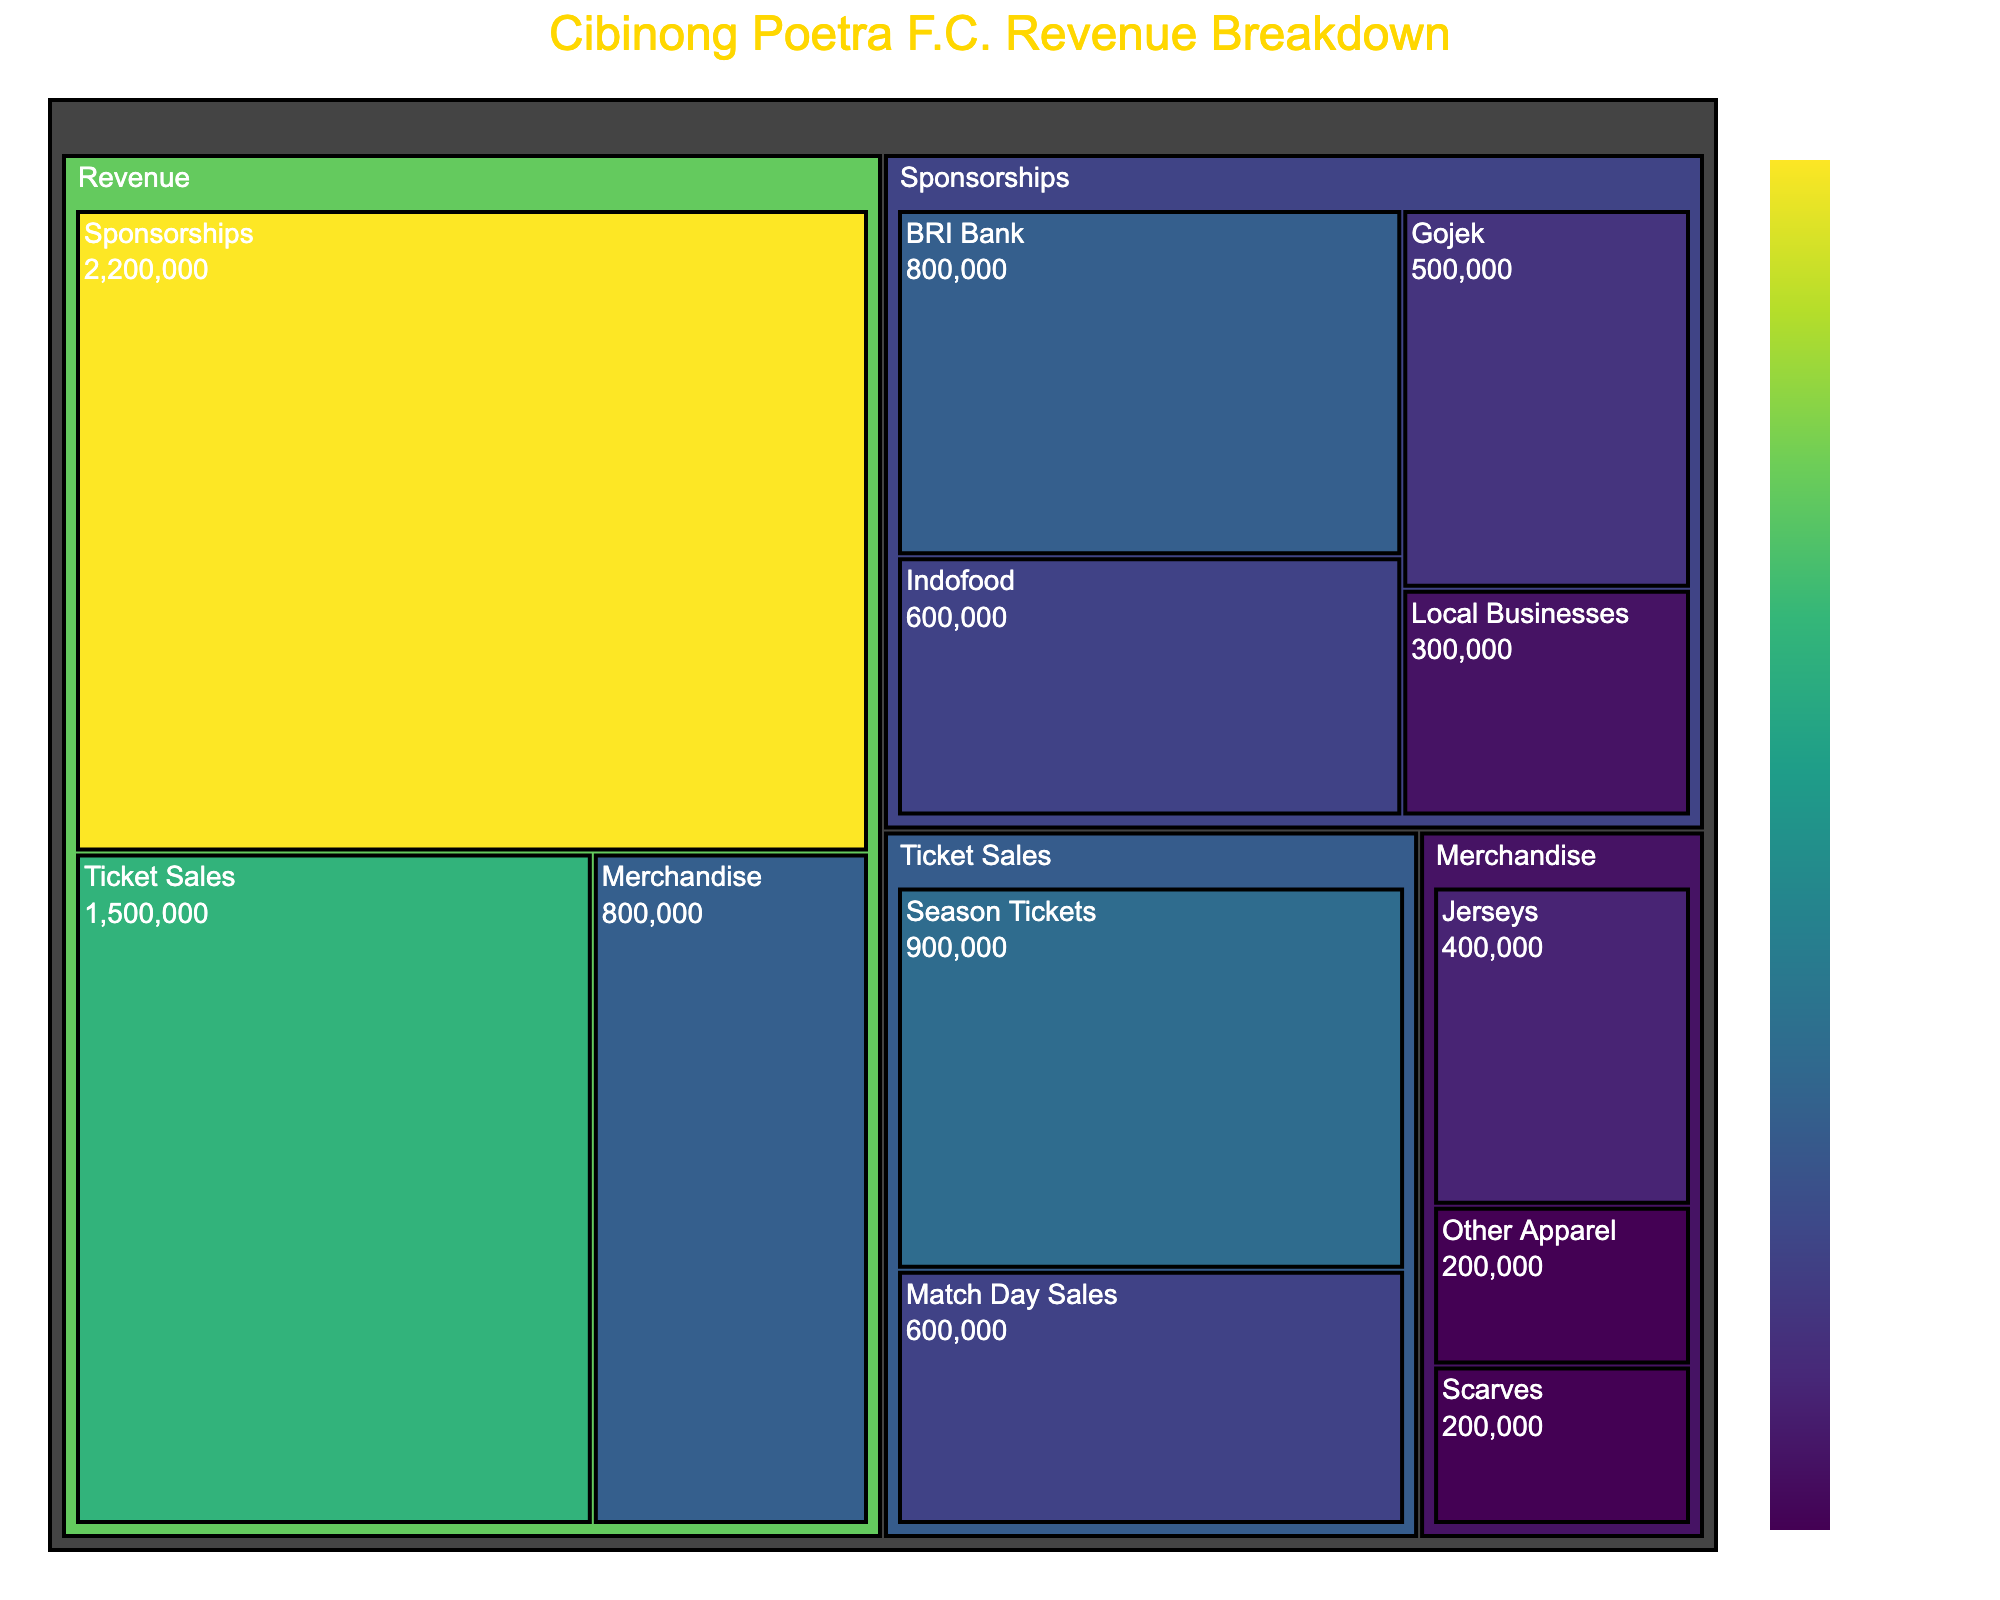What is the title of the figure? The title is usually located at the top center of the figure and specifies what the visualization represents. In this case, it is "Cibinong Poetra F.C. Revenue Breakdown".
Answer: Cibinong Poetra F.C. Revenue Breakdown Which category contributes the most to the revenue? By looking at the largest area within the treemap, one can identify the category that contributes the most. Here, 'Sponsorships' has the largest space, indicating the highest contribution.
Answer: Sponsorships What is the revenue generated from match day sales of tickets? Locate 'Ticket Sales' in the treemap, then find 'Match Day Sales'. The corresponding value in the treemap is IDR 600,000.
Answer: IDR 600,000 How does merchandise revenue from jerseys compare to scarves? Compare the values of 'Jerseys' and 'Scarves' under 'Merchandise'. Jerseys generate IDR 400,000 while Scarves generate IDR 200,000. Jerseys thus generate double the revenue of Scarves.
Answer: Jerseys generate twice the revenue of Scarves What is the combined revenue from BRI Bank and Indofood sponsorships? Sum the values of 'BRI Bank' and 'Indofood' under 'Sponsorships'. The values are 800,000 and 600,000 respectively. So, the total is 800,000 + 600,000 = 1,400,000.
Answer: IDR 1,400,000 Which subcategory has the lowest revenue under sponsorships? Within the 'Sponsorships' category, assess the values of the subcategories. 'Local Businesses' has the smallest value of IDR 300,000.
Answer: Local Businesses What portion of the total revenue does merchandise contribute? To find the portion, you need the total revenue and the merchandise revenue. Total revenue is (1500000 + 800000 + 2200000 = 4500000) and merchandise revenue is 800,000. So, portion is 800,000 / 4,500,000 ≈ 0.178 or 17.8%.
Answer: 17.8% How much more do season tickets generate compared to match day sales? Compare the values directly. Season Tickets generate IDR 900,000 and Match Day Sales generate IDR 600,000. The difference is 900,000 - 600,000 = 300,000.
Answer: IDR 300,000 Rank all subcategories under sponsorships from highest to lowest revenue. Order the subcategories under 'Sponsorships' by their values: BRI Bank (800,000), Indofood (600,000), Gojek (500,000), Local Businesses (300,000).
Answer: BRI Bank, Indofood, Gojek, Local Businesses What is the average revenue for all merchandise subcategories? Sum the values of all merchandise subcategories: (400,000 + 200,000 + 200,000 = 800,000) and divide by the number of subcategories (3). The average is 800,000 / 3 ≈ 266,667.
Answer: IDR 266,667 